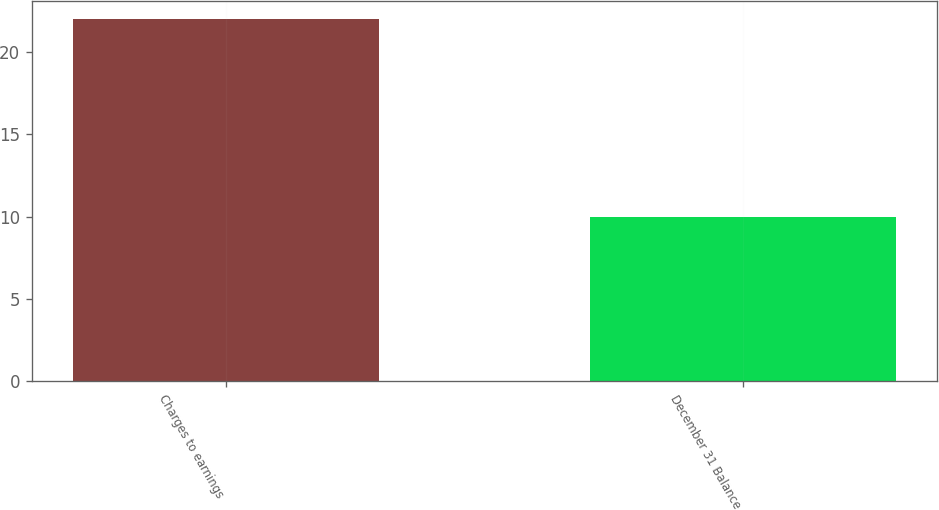Convert chart to OTSL. <chart><loc_0><loc_0><loc_500><loc_500><bar_chart><fcel>Charges to earnings<fcel>December 31 Balance<nl><fcel>22<fcel>10<nl></chart> 